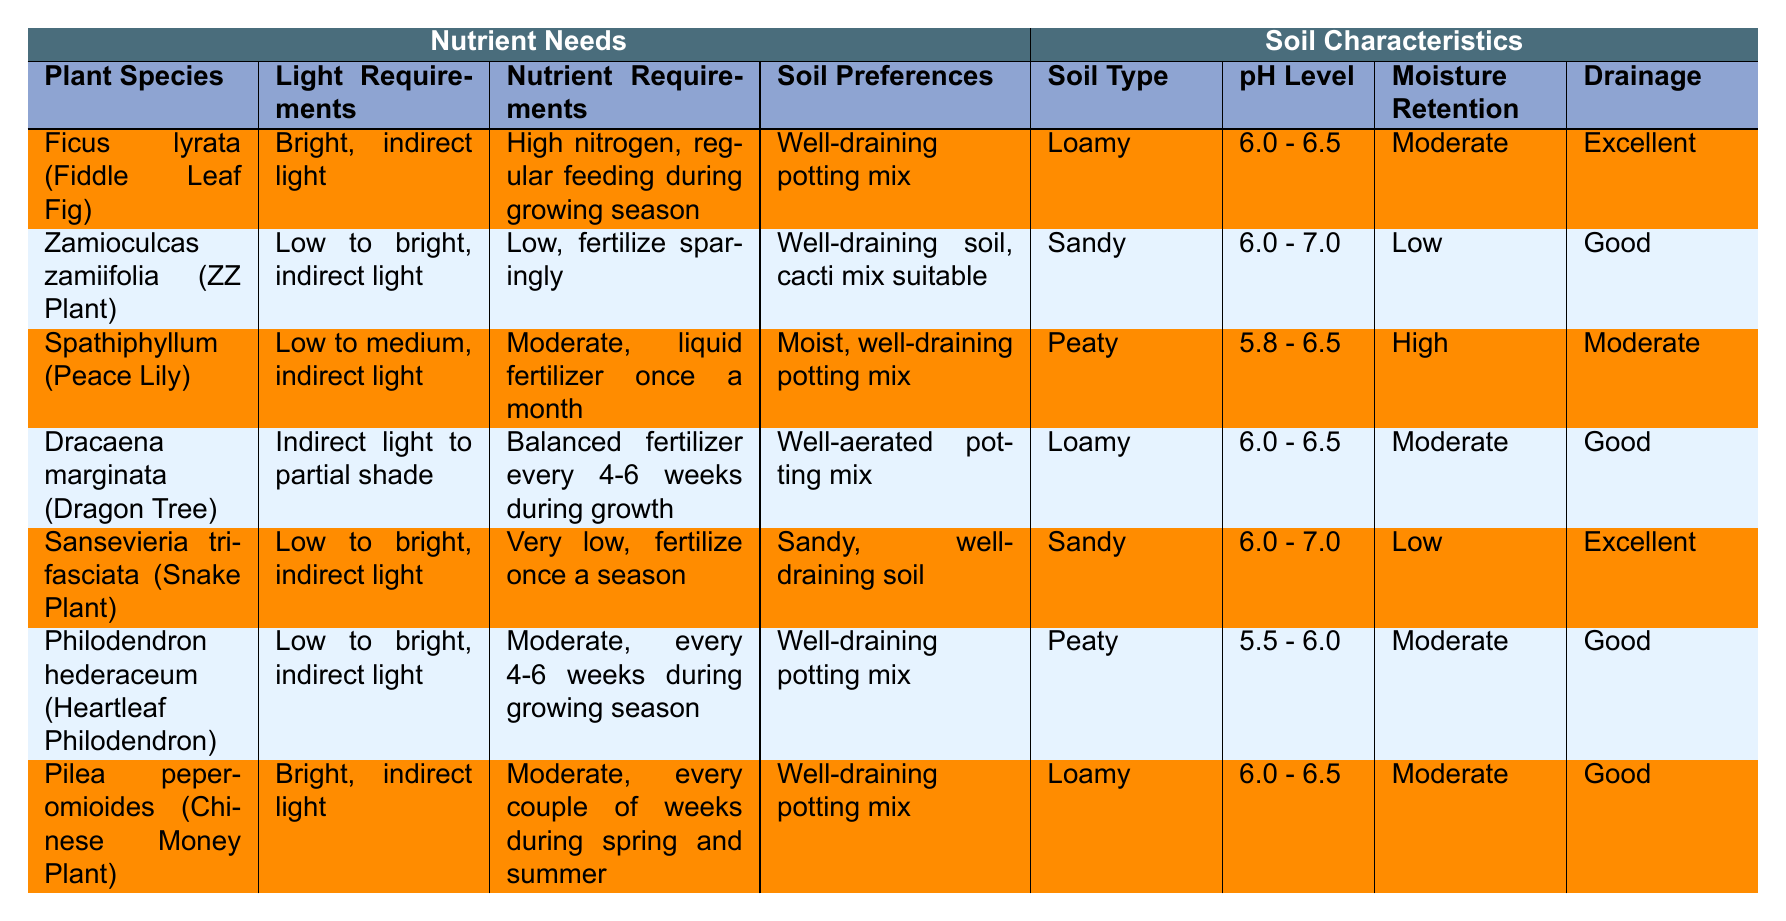What are the light requirements for Ficus lyrata? According to the table, Ficus lyrata (Fiddle Leaf Fig) requires bright, indirect light.
Answer: Bright, indirect light Which plant species has the highest nutrient requirement? From the data, Ficus lyrata has the highest nutrient requirement, which is high nitrogen and regular feeding during the growing season.
Answer: Ficus lyrata What is the pH level range for Sansevieria trifasciata? The pH level range for Sansevieria trifasciata is 6.0 to 7.0, as indicated in the table.
Answer: 6.0 - 7.0 Does Spathiphyllum require high nutrients? No, Spathiphyllum has a moderate nutrient requirement, specifically liquid fertilizer once a month.
Answer: No Which plant has the lowest moisture retention and what is that value? Sansevieria trifasciata has the lowest moisture retention, which is classified as low.
Answer: Low What is the average pH level range of all the plants listed in the table? The pH levels for the plants are: 6.0-6.5, 6.0-7.0, 5.8-6.5, 6.0-6.5, 6.0-7.0, 5.5-6.0, and 6.0-6.5. To find the average, convert the ranges to single values (midpoints): 6.25, 6.5, 6.15, 6.25, 6.5, 5.75, and 6.25. The average pH is (6.25 + 6.5 + 6.15 + 6.25 + 6.5 + 5.75 + 6.25) / 7 = 6.25.
Answer: 6.25 Which plant species has the best drainage, and what is its soil preference? The plants with excellent drainage are Ficus lyrata and Sansevieria trifasciata. Ficus lyrata prefers a well-draining potting mix, while Sansevieria trifasciata prefers sandy, well-draining soil.
Answer: Ficus lyrata and Sansevieria trifasciata; well-draining potting mix and sandy soil How often should Dracaena marginata be fertilized? Dracaena marginata requires a balanced fertilizer every 4-6 weeks during the growth period, as specified in the nutrient requirements.
Answer: Every 4-6 weeks Which plant prefers a peaty soil type? According to the table, Spathiphyllum and Philodendron hederaceum prefer a peaty soil type.
Answer: Spathiphyllum and Philodendron hederaceum Identify the plants that thrive in low light conditions. The plants suitable for low-light conditions are Zamioculcas zamiifolia, Spathiphyllum, Dracaena marginata, Sansevieria trifasciata, and Philodendron hederaceum as noted in their light requirements.
Answer: Zamioculcas zamiifolia, Spathiphyllum, Dracaena marginata, Sansevieria trifasciata, Philodendron hederaceum What soil type do plants requiring high moisture retention prefer? Spathiphyllum has high moisture retention and prefers moist, well-draining potting mix according to the table.
Answer: Peaty 